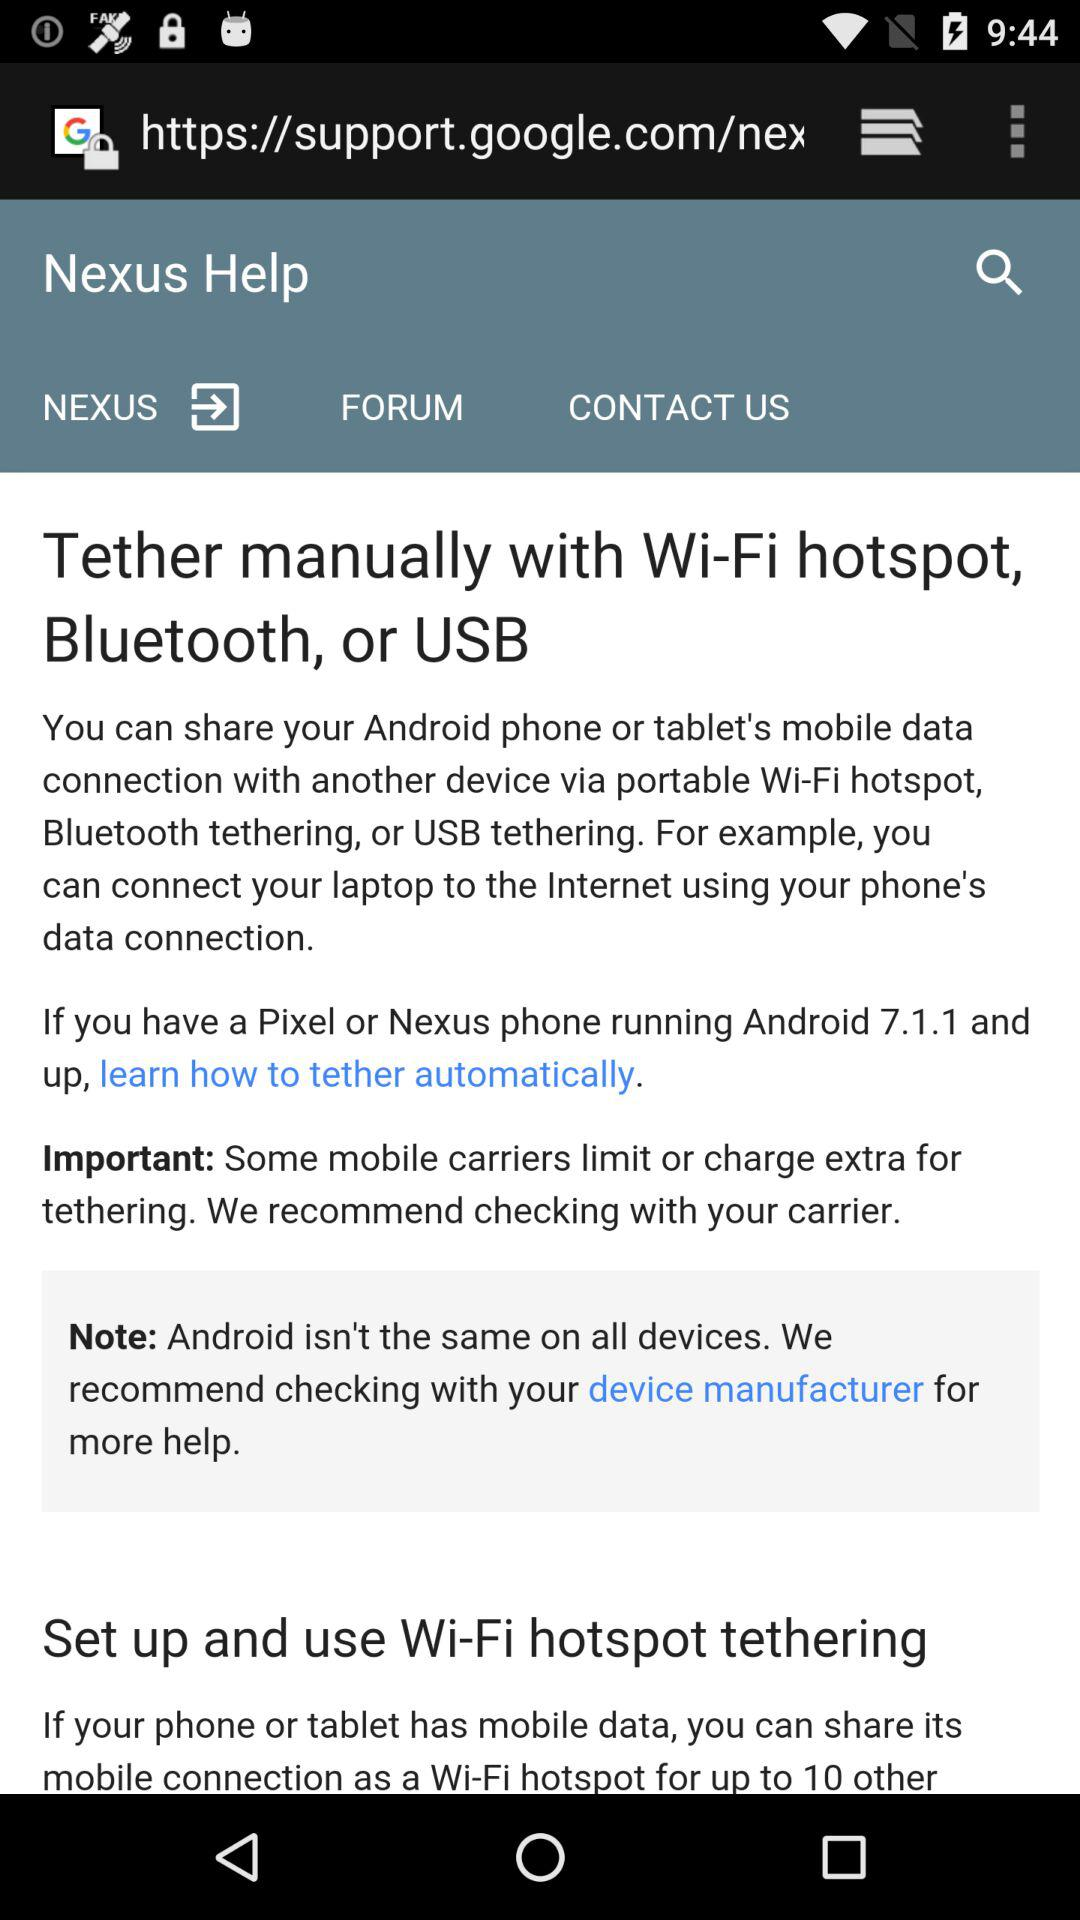How many different ways can you tether your device?
Answer the question using a single word or phrase. 3 